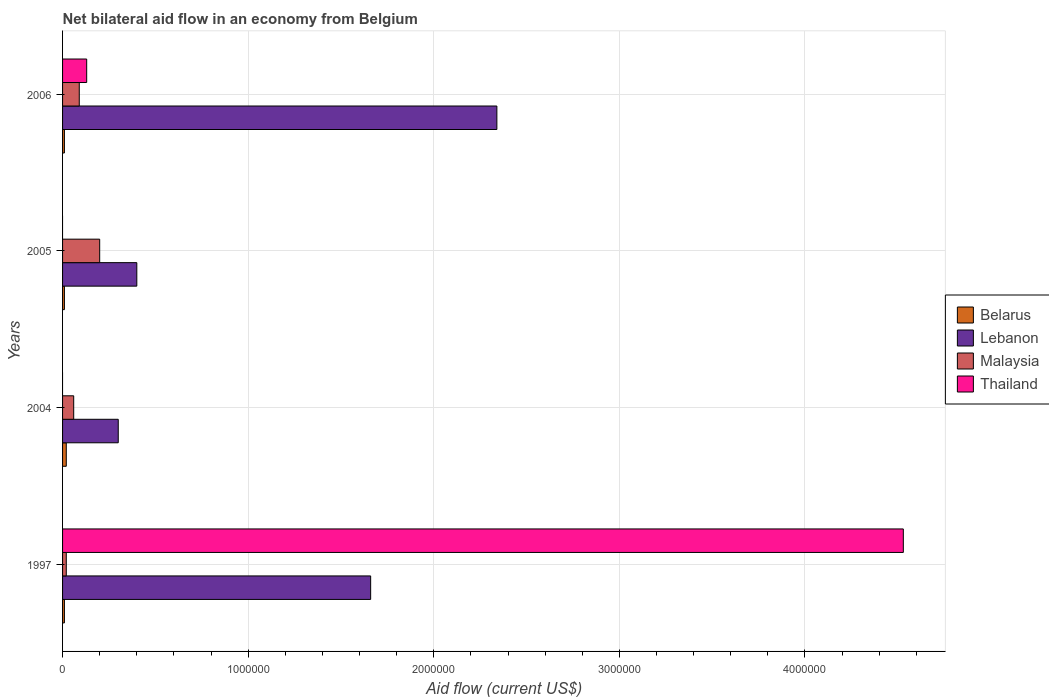How many groups of bars are there?
Offer a very short reply. 4. Are the number of bars per tick equal to the number of legend labels?
Keep it short and to the point. No. How many bars are there on the 2nd tick from the bottom?
Your answer should be compact. 3. In how many cases, is the number of bars for a given year not equal to the number of legend labels?
Offer a very short reply. 2. Across all years, what is the maximum net bilateral aid flow in Lebanon?
Make the answer very short. 2.34e+06. What is the total net bilateral aid flow in Thailand in the graph?
Ensure brevity in your answer.  4.66e+06. What is the difference between the net bilateral aid flow in Belarus in 1997 and that in 2006?
Offer a terse response. 0. What is the average net bilateral aid flow in Thailand per year?
Ensure brevity in your answer.  1.16e+06. In the year 1997, what is the difference between the net bilateral aid flow in Malaysia and net bilateral aid flow in Lebanon?
Give a very brief answer. -1.64e+06. What is the difference between the highest and the second highest net bilateral aid flow in Lebanon?
Provide a short and direct response. 6.80e+05. Is it the case that in every year, the sum of the net bilateral aid flow in Lebanon and net bilateral aid flow in Belarus is greater than the sum of net bilateral aid flow in Thailand and net bilateral aid flow in Malaysia?
Make the answer very short. No. How many bars are there?
Keep it short and to the point. 14. Are all the bars in the graph horizontal?
Ensure brevity in your answer.  Yes. How many years are there in the graph?
Provide a succinct answer. 4. Are the values on the major ticks of X-axis written in scientific E-notation?
Provide a succinct answer. No. Does the graph contain any zero values?
Keep it short and to the point. Yes. Does the graph contain grids?
Your answer should be very brief. Yes. Where does the legend appear in the graph?
Keep it short and to the point. Center right. How many legend labels are there?
Keep it short and to the point. 4. How are the legend labels stacked?
Your answer should be compact. Vertical. What is the title of the graph?
Offer a very short reply. Net bilateral aid flow in an economy from Belgium. What is the Aid flow (current US$) of Lebanon in 1997?
Give a very brief answer. 1.66e+06. What is the Aid flow (current US$) of Thailand in 1997?
Keep it short and to the point. 4.53e+06. What is the Aid flow (current US$) of Lebanon in 2004?
Offer a terse response. 3.00e+05. What is the Aid flow (current US$) in Thailand in 2004?
Your response must be concise. 0. What is the Aid flow (current US$) of Malaysia in 2005?
Provide a short and direct response. 2.00e+05. What is the Aid flow (current US$) in Belarus in 2006?
Give a very brief answer. 10000. What is the Aid flow (current US$) of Lebanon in 2006?
Your response must be concise. 2.34e+06. What is the Aid flow (current US$) of Thailand in 2006?
Your answer should be compact. 1.30e+05. Across all years, what is the maximum Aid flow (current US$) in Belarus?
Make the answer very short. 2.00e+04. Across all years, what is the maximum Aid flow (current US$) in Lebanon?
Keep it short and to the point. 2.34e+06. Across all years, what is the maximum Aid flow (current US$) in Thailand?
Give a very brief answer. 4.53e+06. What is the total Aid flow (current US$) in Belarus in the graph?
Give a very brief answer. 5.00e+04. What is the total Aid flow (current US$) in Lebanon in the graph?
Your response must be concise. 4.70e+06. What is the total Aid flow (current US$) of Thailand in the graph?
Make the answer very short. 4.66e+06. What is the difference between the Aid flow (current US$) in Lebanon in 1997 and that in 2004?
Your answer should be very brief. 1.36e+06. What is the difference between the Aid flow (current US$) in Lebanon in 1997 and that in 2005?
Make the answer very short. 1.26e+06. What is the difference between the Aid flow (current US$) in Malaysia in 1997 and that in 2005?
Give a very brief answer. -1.80e+05. What is the difference between the Aid flow (current US$) of Lebanon in 1997 and that in 2006?
Keep it short and to the point. -6.80e+05. What is the difference between the Aid flow (current US$) in Thailand in 1997 and that in 2006?
Ensure brevity in your answer.  4.40e+06. What is the difference between the Aid flow (current US$) of Belarus in 2004 and that in 2005?
Provide a succinct answer. 10000. What is the difference between the Aid flow (current US$) of Lebanon in 2004 and that in 2005?
Your response must be concise. -1.00e+05. What is the difference between the Aid flow (current US$) in Malaysia in 2004 and that in 2005?
Offer a terse response. -1.40e+05. What is the difference between the Aid flow (current US$) in Belarus in 2004 and that in 2006?
Give a very brief answer. 10000. What is the difference between the Aid flow (current US$) in Lebanon in 2004 and that in 2006?
Make the answer very short. -2.04e+06. What is the difference between the Aid flow (current US$) in Lebanon in 2005 and that in 2006?
Make the answer very short. -1.94e+06. What is the difference between the Aid flow (current US$) of Malaysia in 2005 and that in 2006?
Ensure brevity in your answer.  1.10e+05. What is the difference between the Aid flow (current US$) in Belarus in 1997 and the Aid flow (current US$) in Malaysia in 2004?
Offer a very short reply. -5.00e+04. What is the difference between the Aid flow (current US$) in Lebanon in 1997 and the Aid flow (current US$) in Malaysia in 2004?
Your answer should be very brief. 1.60e+06. What is the difference between the Aid flow (current US$) in Belarus in 1997 and the Aid flow (current US$) in Lebanon in 2005?
Ensure brevity in your answer.  -3.90e+05. What is the difference between the Aid flow (current US$) in Lebanon in 1997 and the Aid flow (current US$) in Malaysia in 2005?
Offer a very short reply. 1.46e+06. What is the difference between the Aid flow (current US$) of Belarus in 1997 and the Aid flow (current US$) of Lebanon in 2006?
Keep it short and to the point. -2.33e+06. What is the difference between the Aid flow (current US$) of Lebanon in 1997 and the Aid flow (current US$) of Malaysia in 2006?
Your answer should be very brief. 1.57e+06. What is the difference between the Aid flow (current US$) of Lebanon in 1997 and the Aid flow (current US$) of Thailand in 2006?
Give a very brief answer. 1.53e+06. What is the difference between the Aid flow (current US$) of Belarus in 2004 and the Aid flow (current US$) of Lebanon in 2005?
Ensure brevity in your answer.  -3.80e+05. What is the difference between the Aid flow (current US$) of Belarus in 2004 and the Aid flow (current US$) of Malaysia in 2005?
Offer a terse response. -1.80e+05. What is the difference between the Aid flow (current US$) in Lebanon in 2004 and the Aid flow (current US$) in Malaysia in 2005?
Offer a very short reply. 1.00e+05. What is the difference between the Aid flow (current US$) in Belarus in 2004 and the Aid flow (current US$) in Lebanon in 2006?
Your answer should be very brief. -2.32e+06. What is the difference between the Aid flow (current US$) of Belarus in 2004 and the Aid flow (current US$) of Malaysia in 2006?
Offer a very short reply. -7.00e+04. What is the difference between the Aid flow (current US$) in Belarus in 2004 and the Aid flow (current US$) in Thailand in 2006?
Offer a very short reply. -1.10e+05. What is the difference between the Aid flow (current US$) in Lebanon in 2004 and the Aid flow (current US$) in Malaysia in 2006?
Provide a succinct answer. 2.10e+05. What is the difference between the Aid flow (current US$) of Belarus in 2005 and the Aid flow (current US$) of Lebanon in 2006?
Your response must be concise. -2.33e+06. What is the difference between the Aid flow (current US$) of Belarus in 2005 and the Aid flow (current US$) of Malaysia in 2006?
Ensure brevity in your answer.  -8.00e+04. What is the average Aid flow (current US$) in Belarus per year?
Ensure brevity in your answer.  1.25e+04. What is the average Aid flow (current US$) in Lebanon per year?
Keep it short and to the point. 1.18e+06. What is the average Aid flow (current US$) in Malaysia per year?
Provide a succinct answer. 9.25e+04. What is the average Aid flow (current US$) of Thailand per year?
Make the answer very short. 1.16e+06. In the year 1997, what is the difference between the Aid flow (current US$) of Belarus and Aid flow (current US$) of Lebanon?
Make the answer very short. -1.65e+06. In the year 1997, what is the difference between the Aid flow (current US$) in Belarus and Aid flow (current US$) in Thailand?
Your answer should be compact. -4.52e+06. In the year 1997, what is the difference between the Aid flow (current US$) of Lebanon and Aid flow (current US$) of Malaysia?
Provide a succinct answer. 1.64e+06. In the year 1997, what is the difference between the Aid flow (current US$) in Lebanon and Aid flow (current US$) in Thailand?
Make the answer very short. -2.87e+06. In the year 1997, what is the difference between the Aid flow (current US$) in Malaysia and Aid flow (current US$) in Thailand?
Make the answer very short. -4.51e+06. In the year 2004, what is the difference between the Aid flow (current US$) of Belarus and Aid flow (current US$) of Lebanon?
Give a very brief answer. -2.80e+05. In the year 2004, what is the difference between the Aid flow (current US$) in Belarus and Aid flow (current US$) in Malaysia?
Offer a terse response. -4.00e+04. In the year 2004, what is the difference between the Aid flow (current US$) in Lebanon and Aid flow (current US$) in Malaysia?
Your answer should be compact. 2.40e+05. In the year 2005, what is the difference between the Aid flow (current US$) in Belarus and Aid flow (current US$) in Lebanon?
Your answer should be compact. -3.90e+05. In the year 2005, what is the difference between the Aid flow (current US$) of Belarus and Aid flow (current US$) of Malaysia?
Your answer should be compact. -1.90e+05. In the year 2006, what is the difference between the Aid flow (current US$) of Belarus and Aid flow (current US$) of Lebanon?
Your answer should be compact. -2.33e+06. In the year 2006, what is the difference between the Aid flow (current US$) of Belarus and Aid flow (current US$) of Malaysia?
Your answer should be very brief. -8.00e+04. In the year 2006, what is the difference between the Aid flow (current US$) of Belarus and Aid flow (current US$) of Thailand?
Keep it short and to the point. -1.20e+05. In the year 2006, what is the difference between the Aid flow (current US$) of Lebanon and Aid flow (current US$) of Malaysia?
Offer a very short reply. 2.25e+06. In the year 2006, what is the difference between the Aid flow (current US$) of Lebanon and Aid flow (current US$) of Thailand?
Ensure brevity in your answer.  2.21e+06. In the year 2006, what is the difference between the Aid flow (current US$) in Malaysia and Aid flow (current US$) in Thailand?
Your answer should be compact. -4.00e+04. What is the ratio of the Aid flow (current US$) in Belarus in 1997 to that in 2004?
Your answer should be very brief. 0.5. What is the ratio of the Aid flow (current US$) in Lebanon in 1997 to that in 2004?
Give a very brief answer. 5.53. What is the ratio of the Aid flow (current US$) of Belarus in 1997 to that in 2005?
Make the answer very short. 1. What is the ratio of the Aid flow (current US$) in Lebanon in 1997 to that in 2005?
Offer a very short reply. 4.15. What is the ratio of the Aid flow (current US$) of Malaysia in 1997 to that in 2005?
Your response must be concise. 0.1. What is the ratio of the Aid flow (current US$) in Belarus in 1997 to that in 2006?
Provide a succinct answer. 1. What is the ratio of the Aid flow (current US$) in Lebanon in 1997 to that in 2006?
Provide a succinct answer. 0.71. What is the ratio of the Aid flow (current US$) in Malaysia in 1997 to that in 2006?
Offer a terse response. 0.22. What is the ratio of the Aid flow (current US$) of Thailand in 1997 to that in 2006?
Your response must be concise. 34.85. What is the ratio of the Aid flow (current US$) of Belarus in 2004 to that in 2005?
Ensure brevity in your answer.  2. What is the ratio of the Aid flow (current US$) of Lebanon in 2004 to that in 2006?
Your response must be concise. 0.13. What is the ratio of the Aid flow (current US$) of Lebanon in 2005 to that in 2006?
Keep it short and to the point. 0.17. What is the ratio of the Aid flow (current US$) of Malaysia in 2005 to that in 2006?
Provide a short and direct response. 2.22. What is the difference between the highest and the second highest Aid flow (current US$) of Lebanon?
Your response must be concise. 6.80e+05. What is the difference between the highest and the second highest Aid flow (current US$) in Malaysia?
Give a very brief answer. 1.10e+05. What is the difference between the highest and the lowest Aid flow (current US$) in Belarus?
Ensure brevity in your answer.  10000. What is the difference between the highest and the lowest Aid flow (current US$) of Lebanon?
Your answer should be very brief. 2.04e+06. What is the difference between the highest and the lowest Aid flow (current US$) in Thailand?
Offer a very short reply. 4.53e+06. 